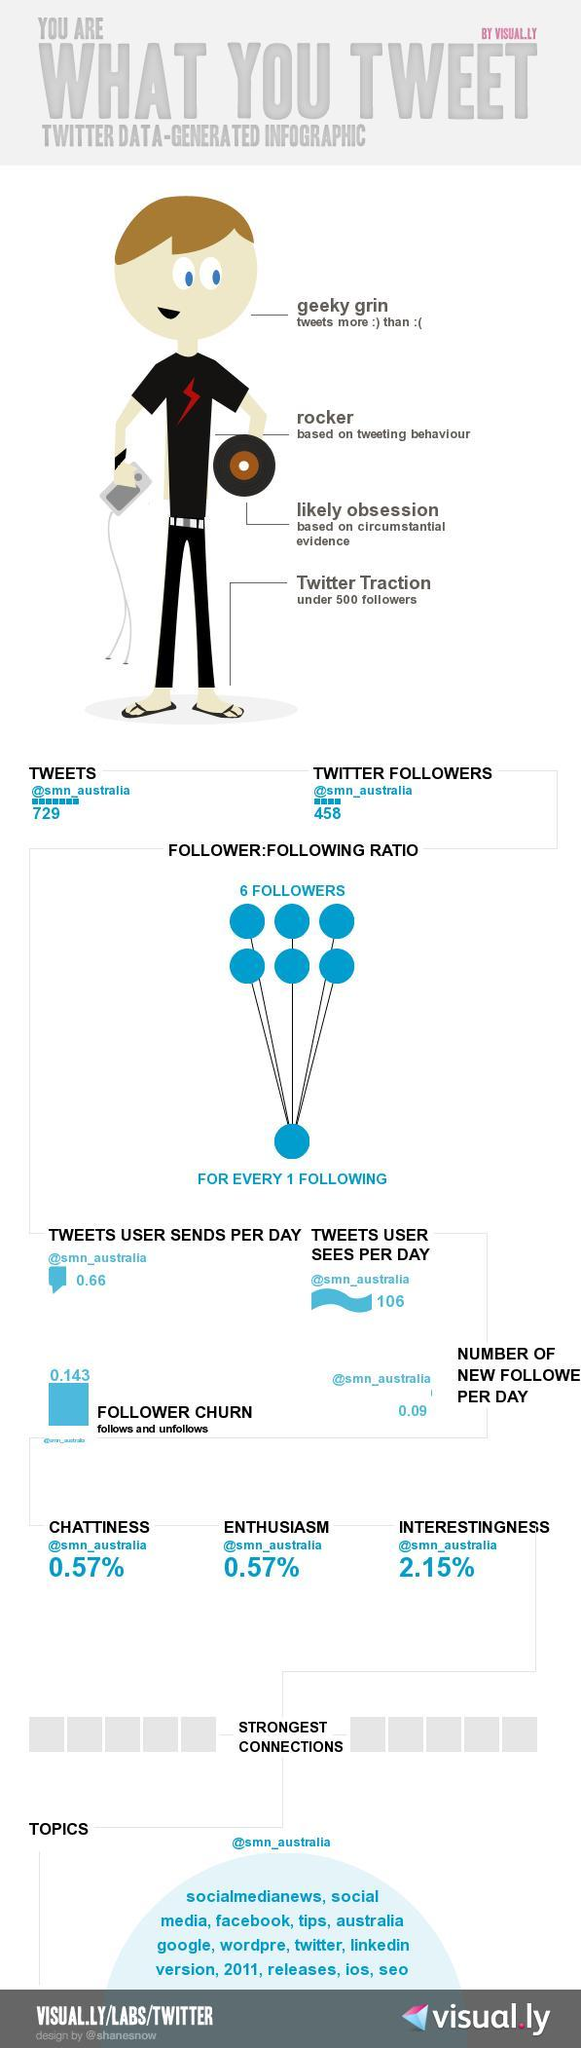What is the percentage of interestingness?
Answer the question with a short phrase. 2.15% How many twitter followers for @smn_australia? 458 what is the number of tweets user sees per day? 106 